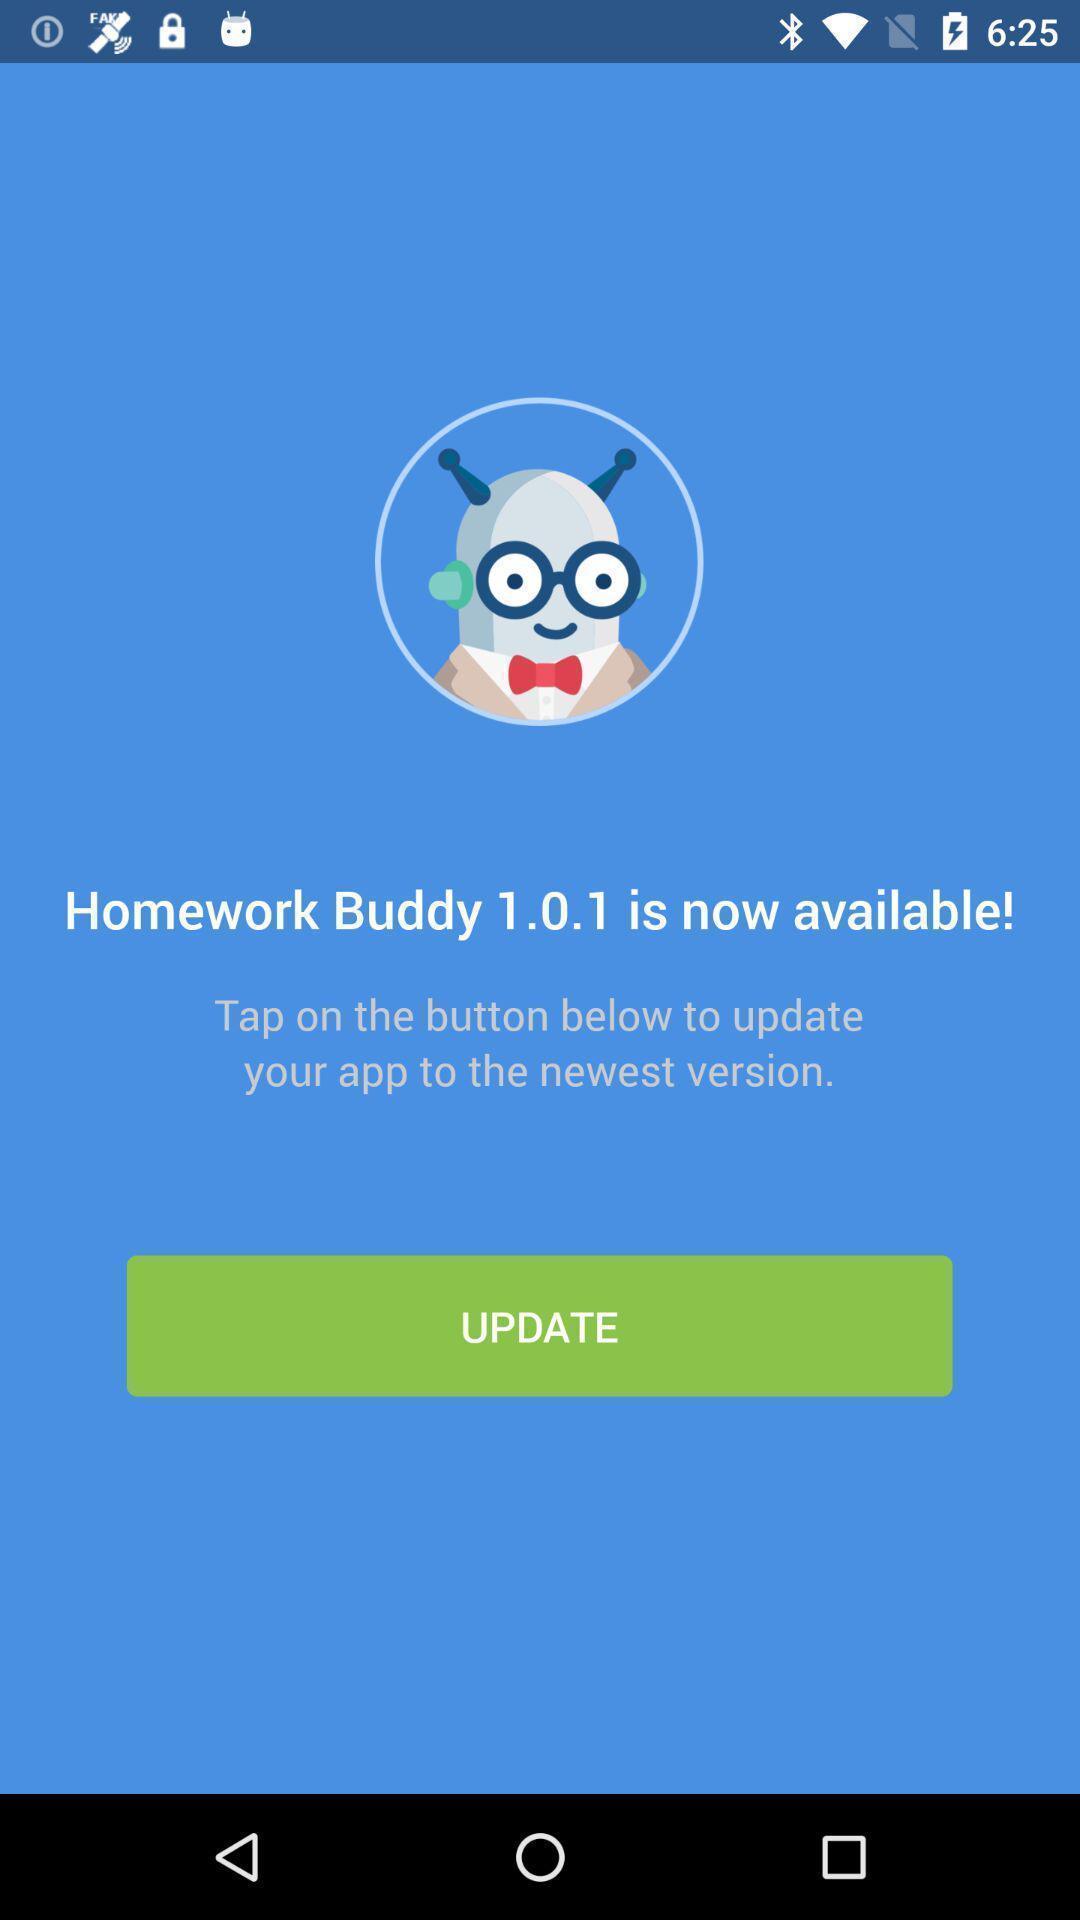Tell me what you see in this picture. Window displaying to update the app. 